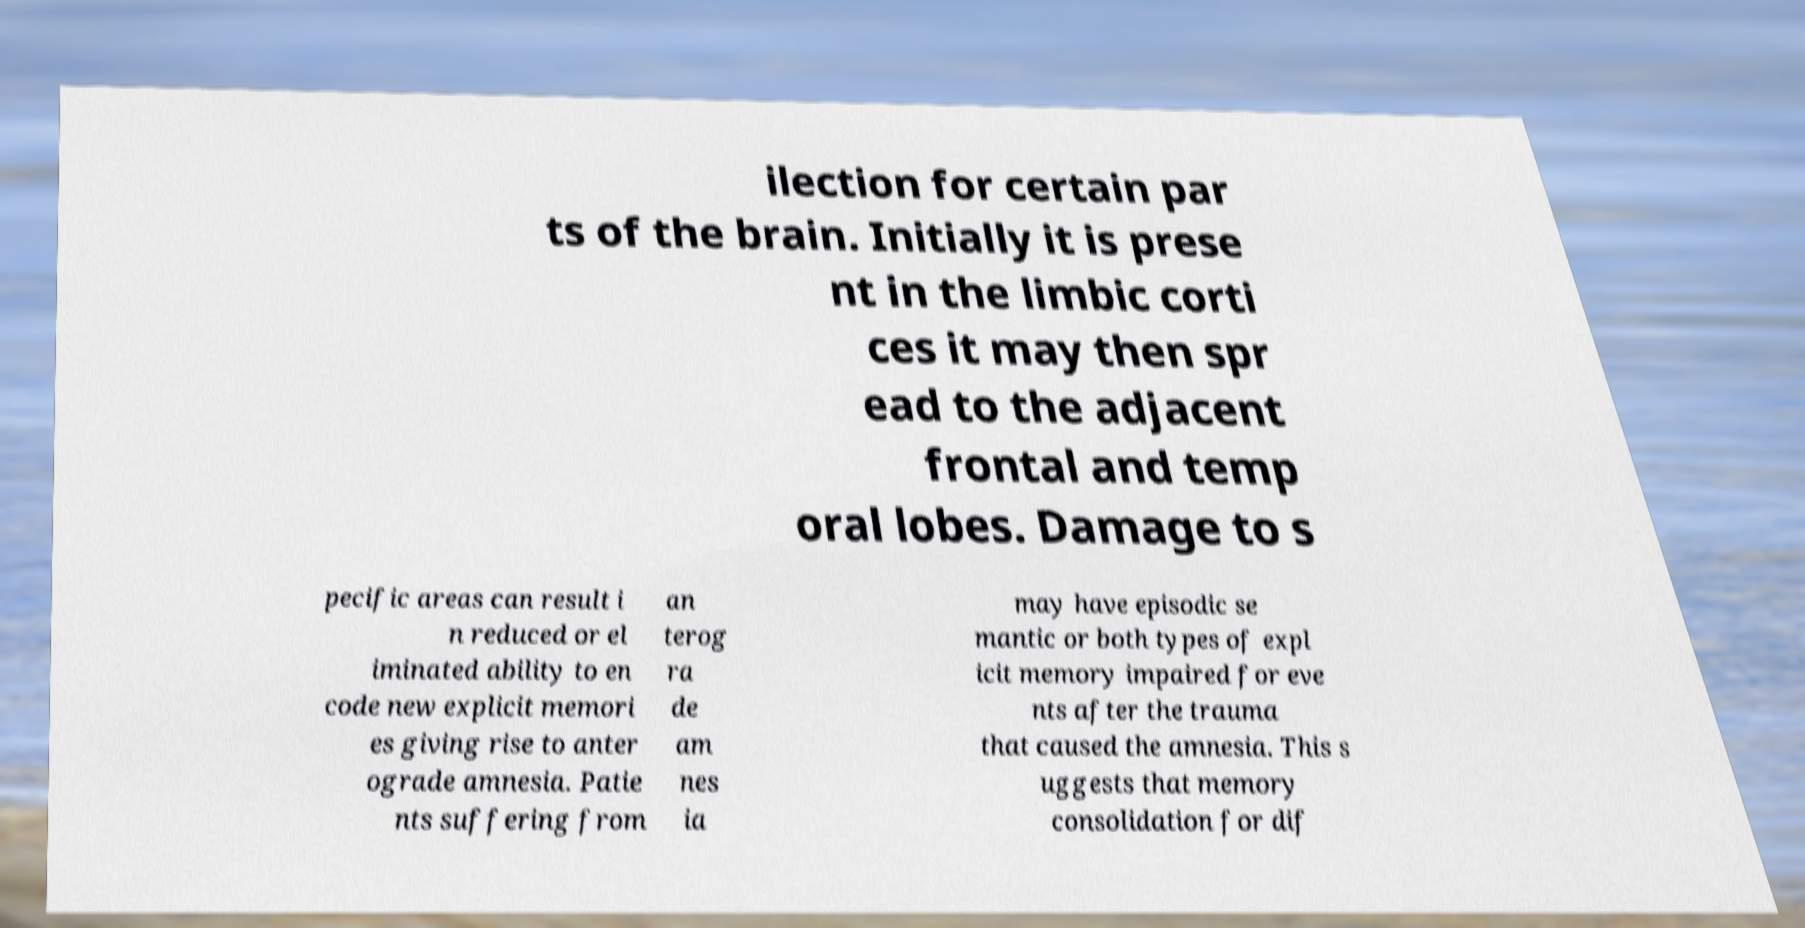What messages or text are displayed in this image? I need them in a readable, typed format. ilection for certain par ts of the brain. Initially it is prese nt in the limbic corti ces it may then spr ead to the adjacent frontal and temp oral lobes. Damage to s pecific areas can result i n reduced or el iminated ability to en code new explicit memori es giving rise to anter ograde amnesia. Patie nts suffering from an terog ra de am nes ia may have episodic se mantic or both types of expl icit memory impaired for eve nts after the trauma that caused the amnesia. This s uggests that memory consolidation for dif 